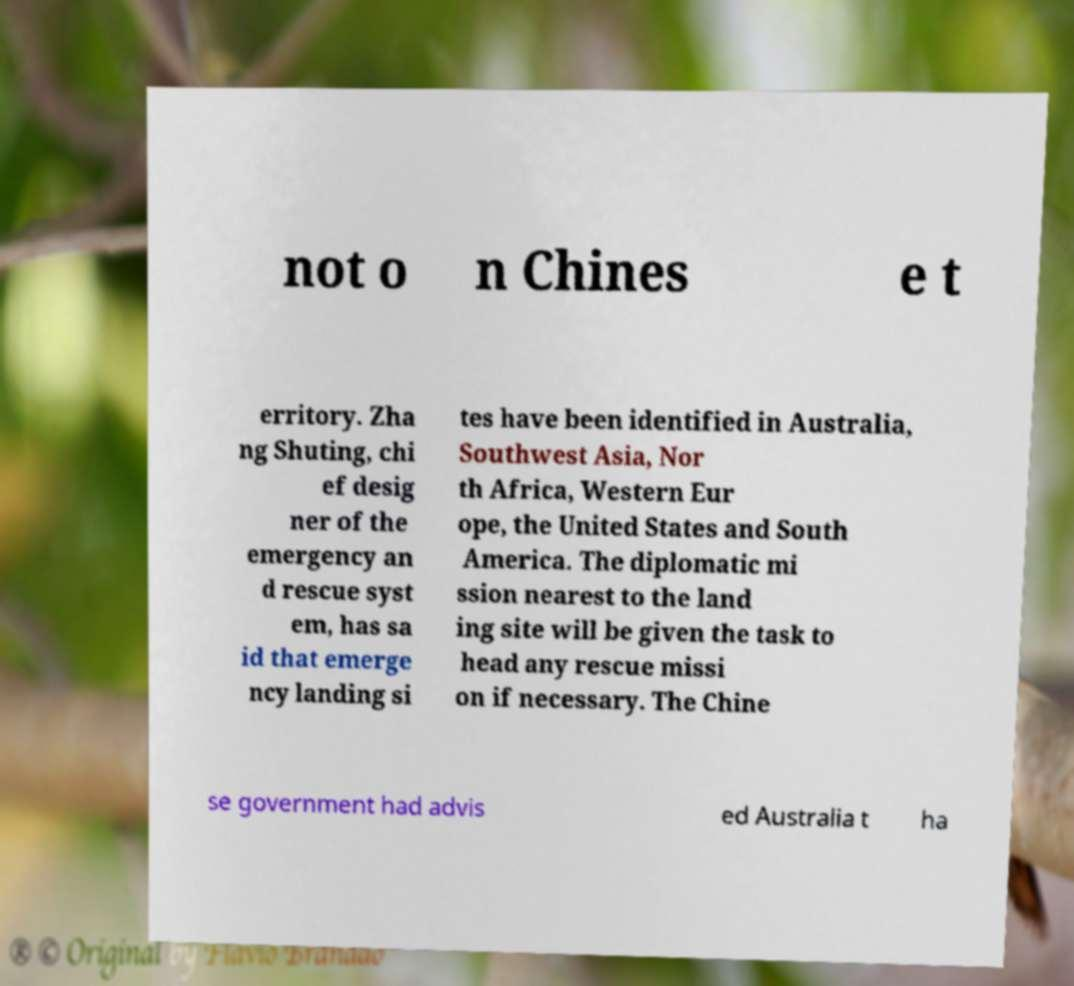There's text embedded in this image that I need extracted. Can you transcribe it verbatim? not o n Chines e t erritory. Zha ng Shuting, chi ef desig ner of the emergency an d rescue syst em, has sa id that emerge ncy landing si tes have been identified in Australia, Southwest Asia, Nor th Africa, Western Eur ope, the United States and South America. The diplomatic mi ssion nearest to the land ing site will be given the task to head any rescue missi on if necessary. The Chine se government had advis ed Australia t ha 